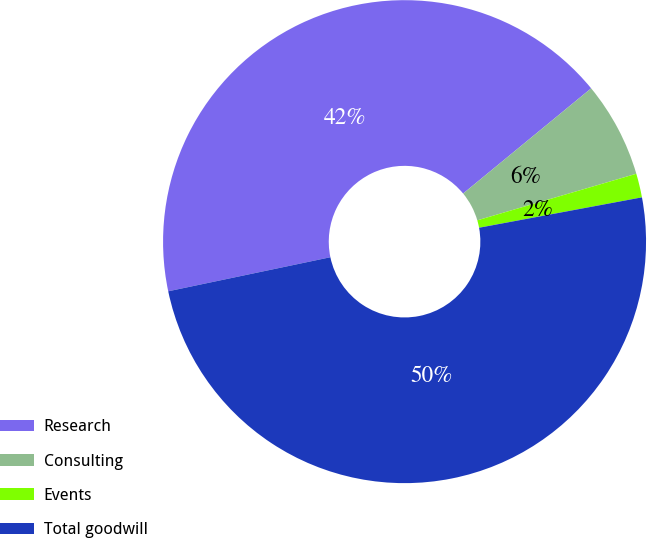Convert chart. <chart><loc_0><loc_0><loc_500><loc_500><pie_chart><fcel>Research<fcel>Consulting<fcel>Events<fcel>Total goodwill<nl><fcel>42.35%<fcel>6.41%<fcel>1.6%<fcel>49.64%<nl></chart> 